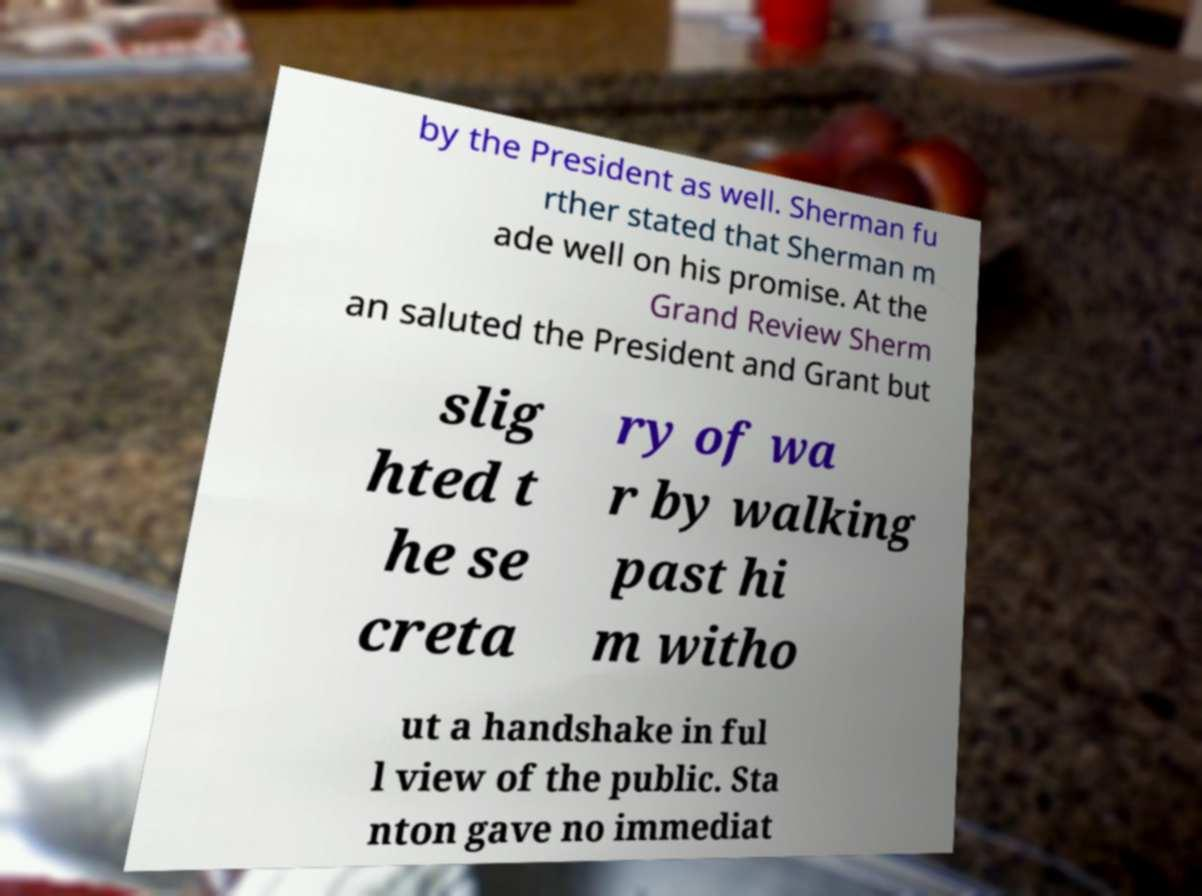I need the written content from this picture converted into text. Can you do that? by the President as well. Sherman fu rther stated that Sherman m ade well on his promise. At the Grand Review Sherm an saluted the President and Grant but slig hted t he se creta ry of wa r by walking past hi m witho ut a handshake in ful l view of the public. Sta nton gave no immediat 